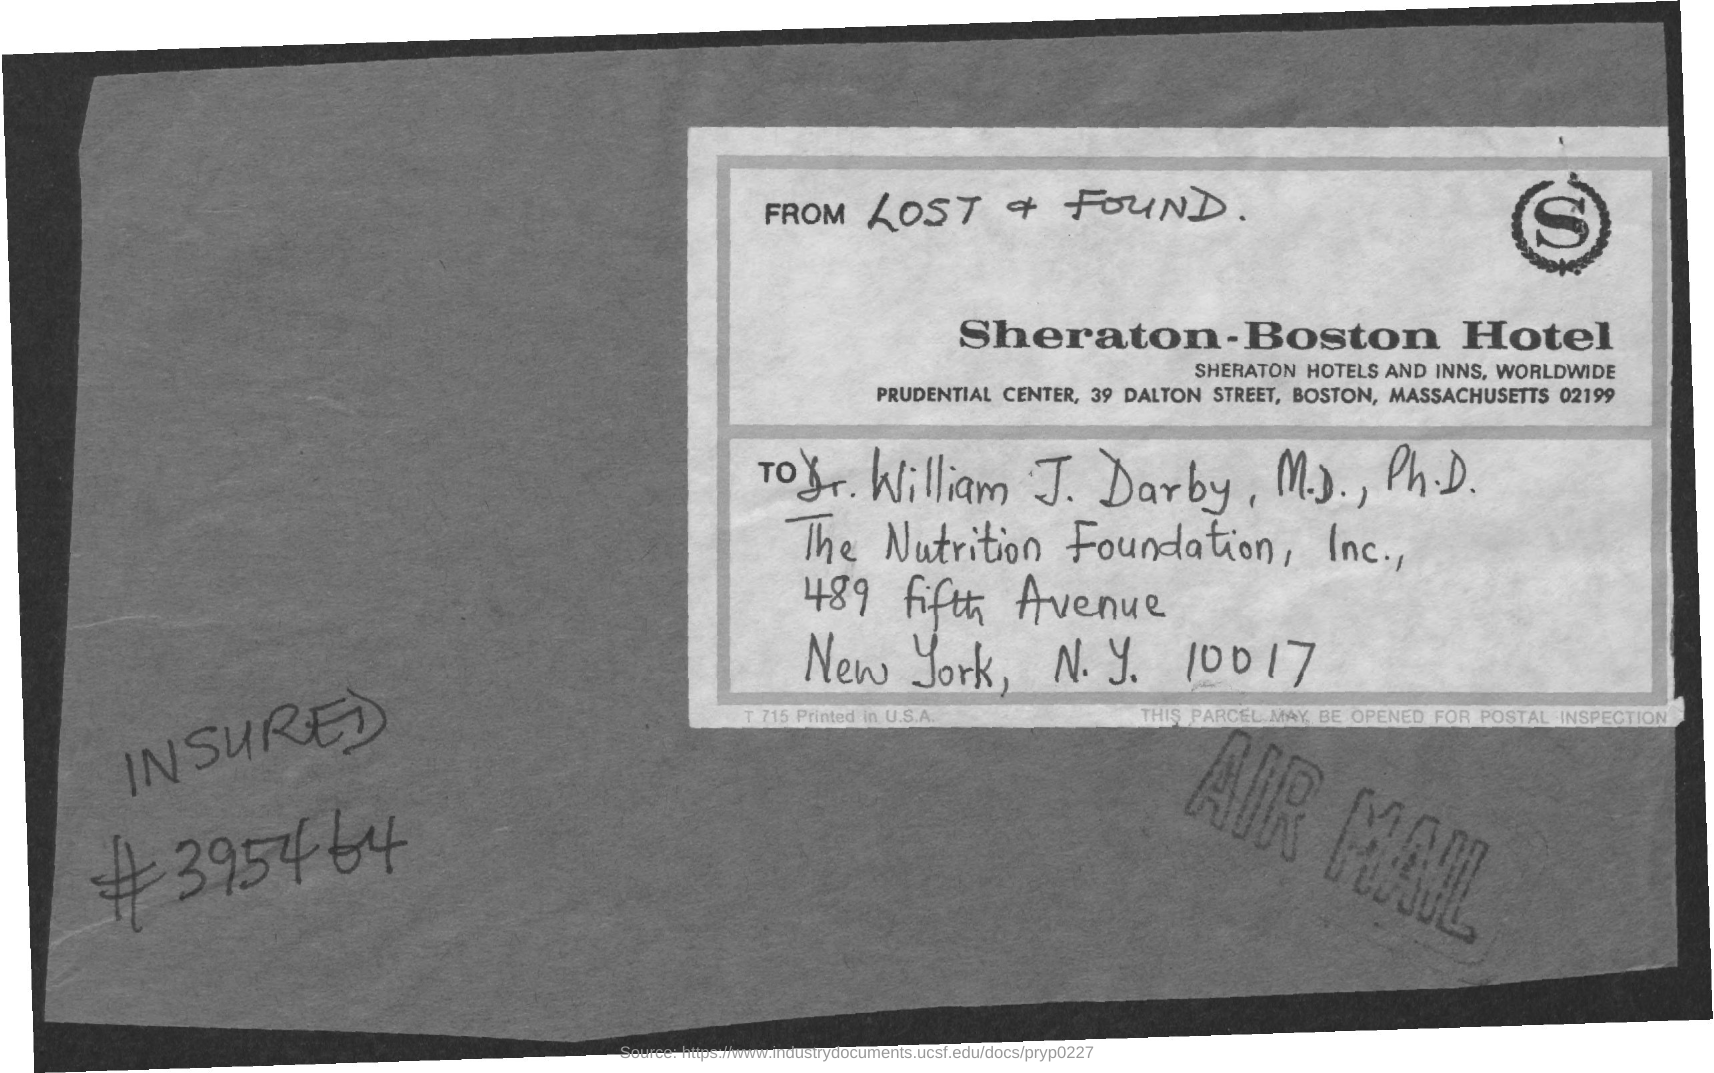Point out several critical features in this image. The person addressed in this text is named Dr. William J. Darby, M.D., Ph.D. The letter 'S' is written in the top-right logo. The name of the hotel is Sheraton-Boston Hotel. The letter is from the Sheraton-Boston Hotel. 